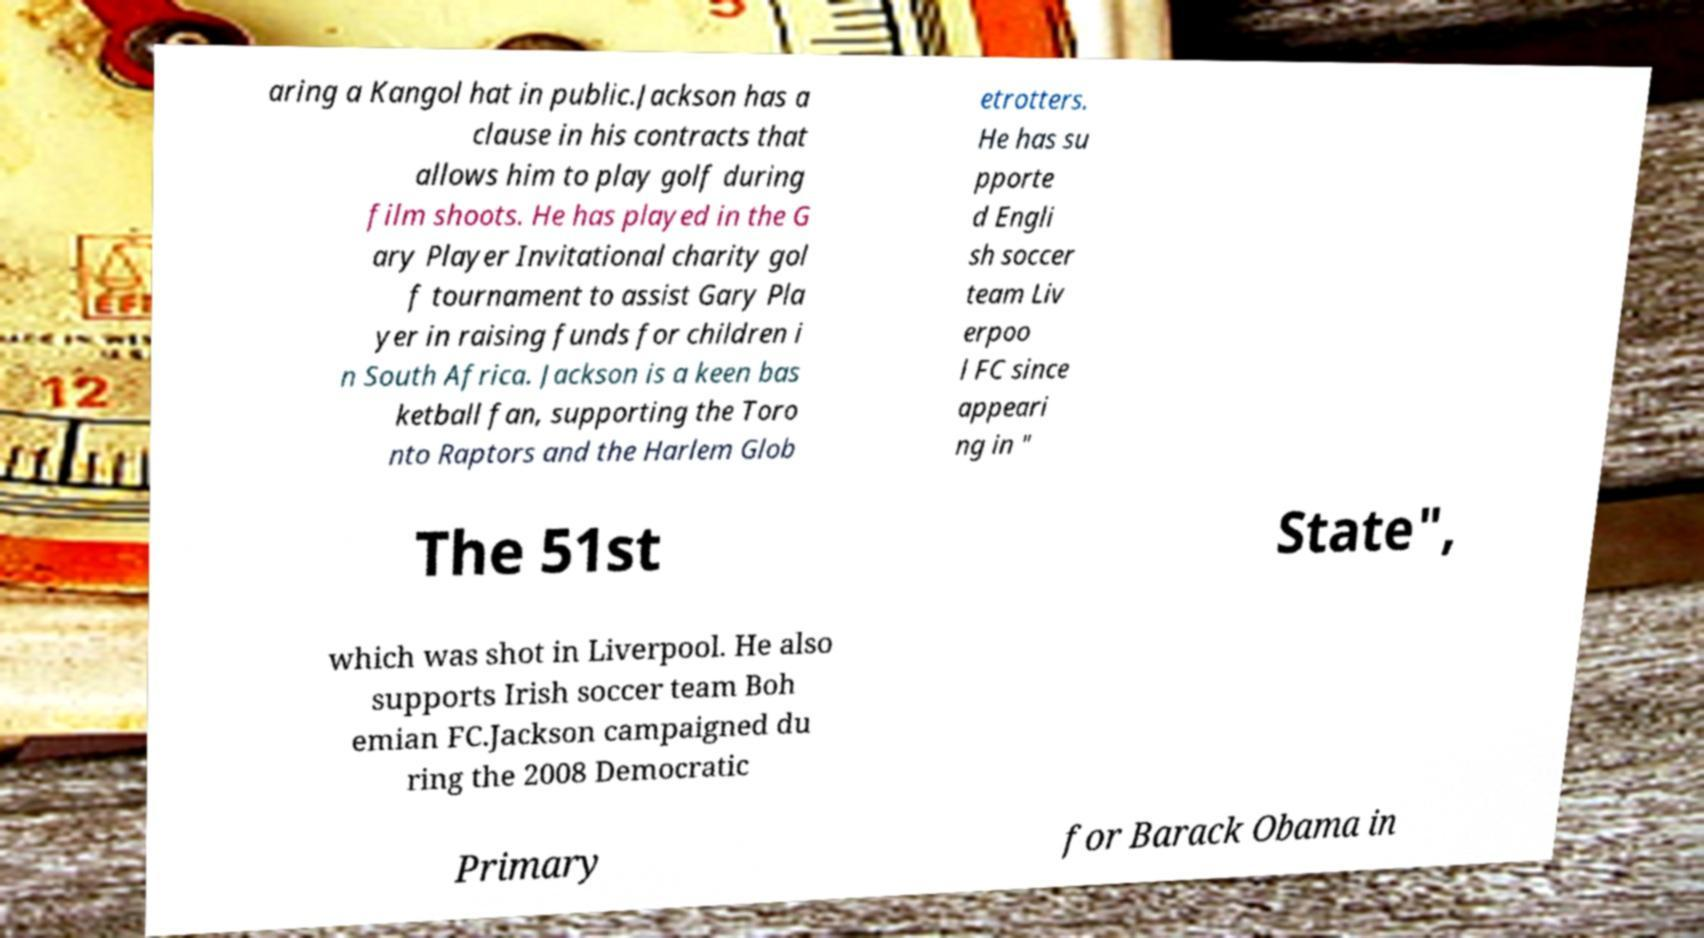Could you extract and type out the text from this image? aring a Kangol hat in public.Jackson has a clause in his contracts that allows him to play golf during film shoots. He has played in the G ary Player Invitational charity gol f tournament to assist Gary Pla yer in raising funds for children i n South Africa. Jackson is a keen bas ketball fan, supporting the Toro nto Raptors and the Harlem Glob etrotters. He has su pporte d Engli sh soccer team Liv erpoo l FC since appeari ng in " The 51st State", which was shot in Liverpool. He also supports Irish soccer team Boh emian FC.Jackson campaigned du ring the 2008 Democratic Primary for Barack Obama in 